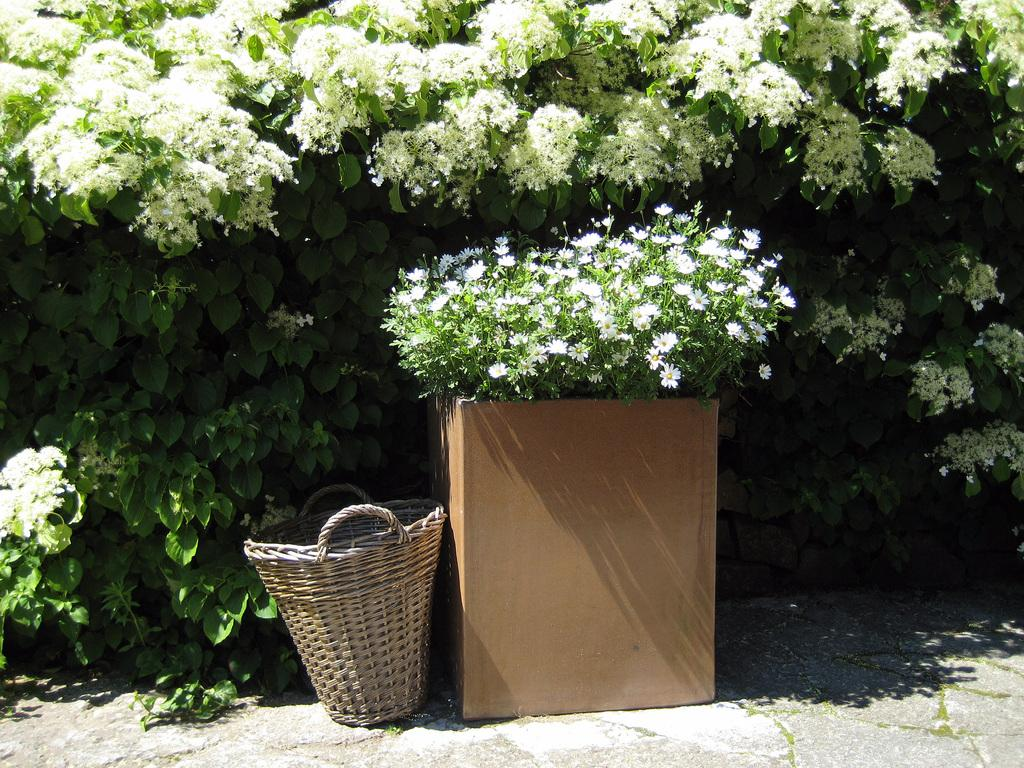What types of vegetation can be seen in the image? There are many plants and flowers in the image. What is the container for the plants in the image? There is a plant pot in the image. What other object can be seen in the image? There is a basket in the image. What type of pancake is being served in the image? There is no pancake present in the image. 